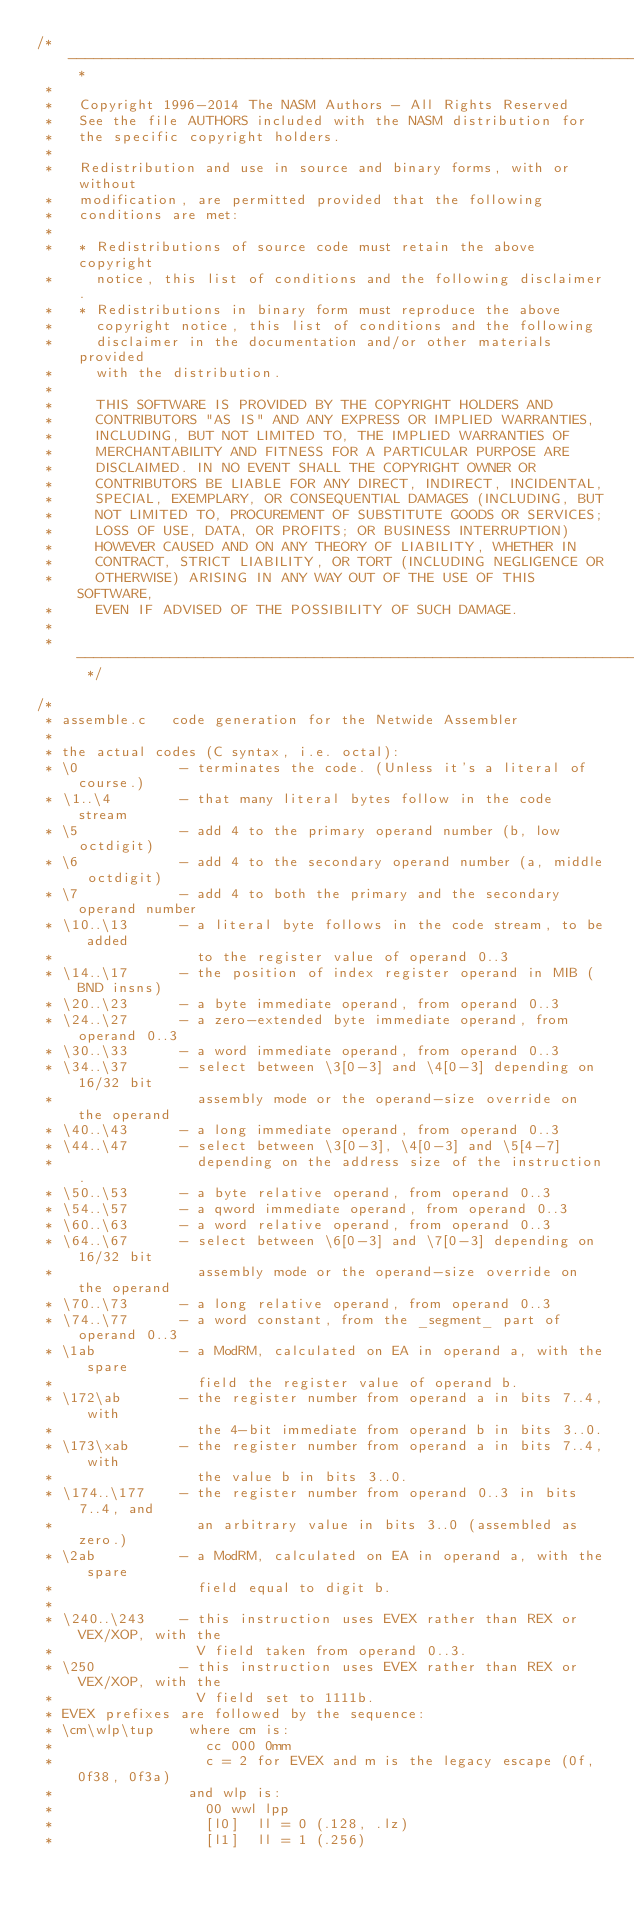<code> <loc_0><loc_0><loc_500><loc_500><_C_>/* ----------------------------------------------------------------------- *
 *
 *   Copyright 1996-2014 The NASM Authors - All Rights Reserved
 *   See the file AUTHORS included with the NASM distribution for
 *   the specific copyright holders.
 *
 *   Redistribution and use in source and binary forms, with or without
 *   modification, are permitted provided that the following
 *   conditions are met:
 *
 *   * Redistributions of source code must retain the above copyright
 *     notice, this list of conditions and the following disclaimer.
 *   * Redistributions in binary form must reproduce the above
 *     copyright notice, this list of conditions and the following
 *     disclaimer in the documentation and/or other materials provided
 *     with the distribution.
 *
 *     THIS SOFTWARE IS PROVIDED BY THE COPYRIGHT HOLDERS AND
 *     CONTRIBUTORS "AS IS" AND ANY EXPRESS OR IMPLIED WARRANTIES,
 *     INCLUDING, BUT NOT LIMITED TO, THE IMPLIED WARRANTIES OF
 *     MERCHANTABILITY AND FITNESS FOR A PARTICULAR PURPOSE ARE
 *     DISCLAIMED. IN NO EVENT SHALL THE COPYRIGHT OWNER OR
 *     CONTRIBUTORS BE LIABLE FOR ANY DIRECT, INDIRECT, INCIDENTAL,
 *     SPECIAL, EXEMPLARY, OR CONSEQUENTIAL DAMAGES (INCLUDING, BUT
 *     NOT LIMITED TO, PROCUREMENT OF SUBSTITUTE GOODS OR SERVICES;
 *     LOSS OF USE, DATA, OR PROFITS; OR BUSINESS INTERRUPTION)
 *     HOWEVER CAUSED AND ON ANY THEORY OF LIABILITY, WHETHER IN
 *     CONTRACT, STRICT LIABILITY, OR TORT (INCLUDING NEGLIGENCE OR
 *     OTHERWISE) ARISING IN ANY WAY OUT OF THE USE OF THIS SOFTWARE,
 *     EVEN IF ADVISED OF THE POSSIBILITY OF SUCH DAMAGE.
 *
 * ----------------------------------------------------------------------- */

/*
 * assemble.c   code generation for the Netwide Assembler
 *
 * the actual codes (C syntax, i.e. octal):
 * \0            - terminates the code. (Unless it's a literal of course.)
 * \1..\4        - that many literal bytes follow in the code stream
 * \5            - add 4 to the primary operand number (b, low octdigit)
 * \6            - add 4 to the secondary operand number (a, middle octdigit)
 * \7            - add 4 to both the primary and the secondary operand number
 * \10..\13      - a literal byte follows in the code stream, to be added
 *                 to the register value of operand 0..3
 * \14..\17      - the position of index register operand in MIB (BND insns)
 * \20..\23      - a byte immediate operand, from operand 0..3
 * \24..\27      - a zero-extended byte immediate operand, from operand 0..3
 * \30..\33      - a word immediate operand, from operand 0..3
 * \34..\37      - select between \3[0-3] and \4[0-3] depending on 16/32 bit
 *                 assembly mode or the operand-size override on the operand
 * \40..\43      - a long immediate operand, from operand 0..3
 * \44..\47      - select between \3[0-3], \4[0-3] and \5[4-7]
 *                 depending on the address size of the instruction.
 * \50..\53      - a byte relative operand, from operand 0..3
 * \54..\57      - a qword immediate operand, from operand 0..3
 * \60..\63      - a word relative operand, from operand 0..3
 * \64..\67      - select between \6[0-3] and \7[0-3] depending on 16/32 bit
 *                 assembly mode or the operand-size override on the operand
 * \70..\73      - a long relative operand, from operand 0..3
 * \74..\77      - a word constant, from the _segment_ part of operand 0..3
 * \1ab          - a ModRM, calculated on EA in operand a, with the spare
 *                 field the register value of operand b.
 * \172\ab       - the register number from operand a in bits 7..4, with
 *                 the 4-bit immediate from operand b in bits 3..0.
 * \173\xab      - the register number from operand a in bits 7..4, with
 *                 the value b in bits 3..0.
 * \174..\177    - the register number from operand 0..3 in bits 7..4, and
 *                 an arbitrary value in bits 3..0 (assembled as zero.)
 * \2ab          - a ModRM, calculated on EA in operand a, with the spare
 *                 field equal to digit b.
 *
 * \240..\243    - this instruction uses EVEX rather than REX or VEX/XOP, with the
 *                 V field taken from operand 0..3.
 * \250          - this instruction uses EVEX rather than REX or VEX/XOP, with the
 *                 V field set to 1111b.
 * EVEX prefixes are followed by the sequence:
 * \cm\wlp\tup    where cm is:
 *                  cc 000 0mm
 *                  c = 2 for EVEX and m is the legacy escape (0f, 0f38, 0f3a)
 *                and wlp is:
 *                  00 wwl lpp
 *                  [l0]  ll = 0 (.128, .lz)
 *                  [l1]  ll = 1 (.256)</code> 